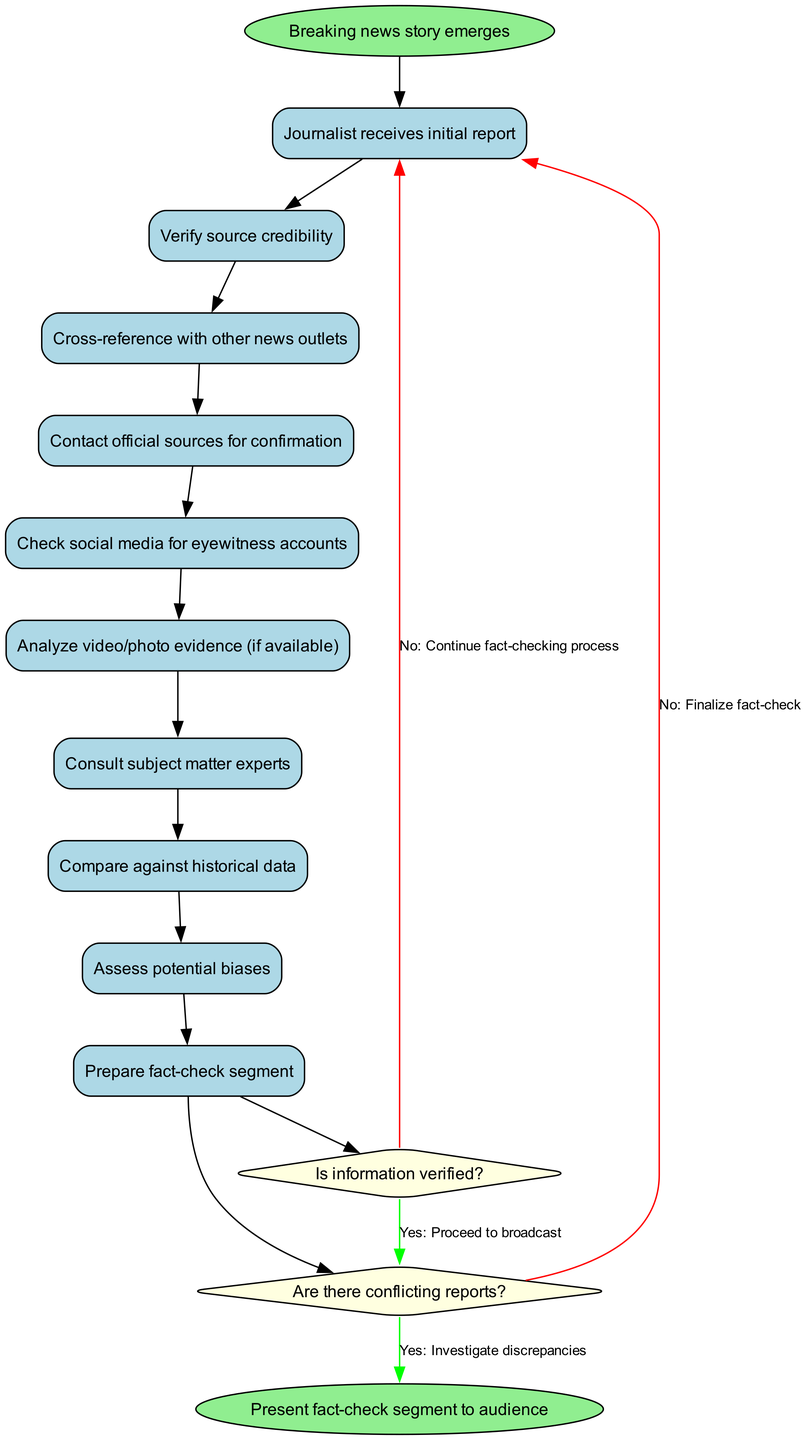What is the first activity in the fact-checking process? The diagram starts with the node labeled "Journalist receives initial report." This is the first activity that initiates the fact-checking process as indicated by the arrow from the start node.
Answer: Journalist receives initial report How many activities are there in total? There are ten activities listed in the diagram, which can be counted from the activities section provided. This includes all steps from receiving the initial report to preparing the fact-check segment.
Answer: 10 What decision follows the last activity? The last activity in the sequence is "Assess potential biases," which leads directly to a decision node. The decision that follows this activity is labeled "Is information verified?" indicating the first checkpoint after the activities.
Answer: Is information verified? What is the outcome if the answer to "Are there conflicting reports?" is yes? If the decision "Are there conflicting reports?" is answered with yes, the flow moves to "Investigate discrepancies." This indicates the process requires further scrutiny of conflicting information before concluding the fact-checking process.
Answer: Investigate discrepancies Which two activities are connected to the final decision node? The final decision node, "Are there conflicting reports?" is connected by incoming edges from the preceding activity "Check social media for eyewitness accounts" and the decision node "Is information verified?" The connection illustrates where the decision-making process branches based on multiple activities.
Answer: Check social media for eyewitness accounts, Is information verified? What happens if information is not verified after the decision "Is information verified?" If the information is not verified, the diagram indicates that the process continues with the fact-checking activities until sufficient confirmation is obtained. The diagram denotes this flow with a red edge leading back to the continuation of fact-checking processes.
Answer: Continue fact-checking process 